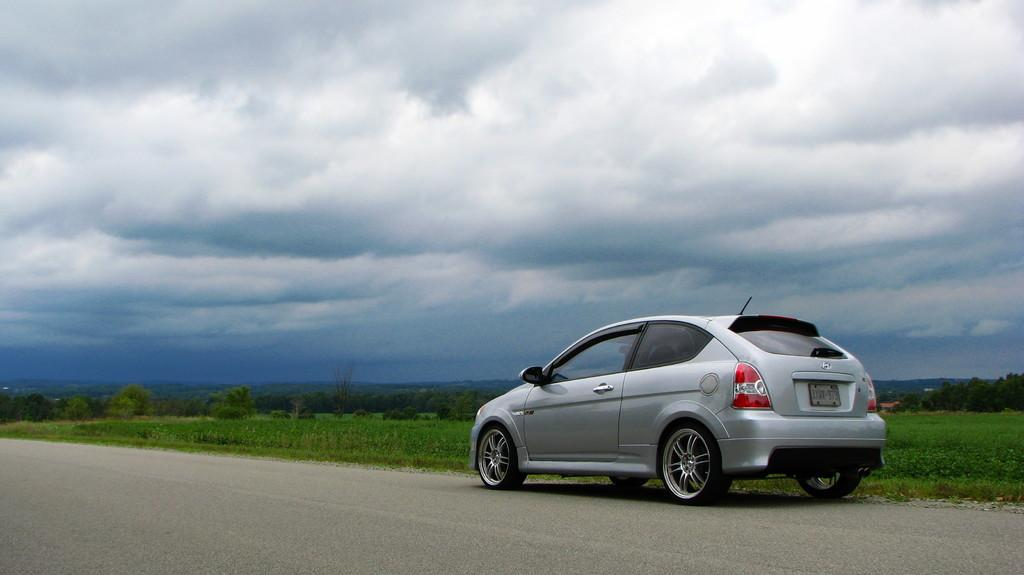What is the main subject of the image? There is a car in the image. What other elements can be seen in the image besides the car? There are plants, trees, and grass visible in the image. What is visible in the background of the image? The sky is visible in the background of the image. What type of notebook is the cat using to write in the image? There is no notebook or cat present in the image. 